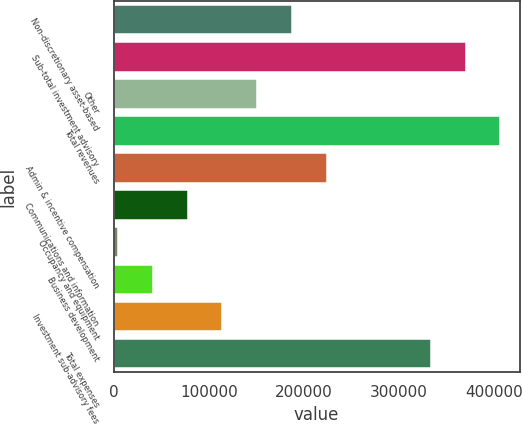<chart> <loc_0><loc_0><loc_500><loc_500><bar_chart><fcel>Non-discretionary asset-based<fcel>Sub-total investment advisory<fcel>Other<fcel>Total revenues<fcel>Admin & incentive compensation<fcel>Communications and information<fcel>Occupancy and equipment<fcel>Business development<fcel>Investment sub-advisory fees<fcel>Total expenses<nl><fcel>187138<fcel>369690<fcel>150628<fcel>406200<fcel>223649<fcel>77607.6<fcel>4587<fcel>41097.3<fcel>114118<fcel>333180<nl></chart> 